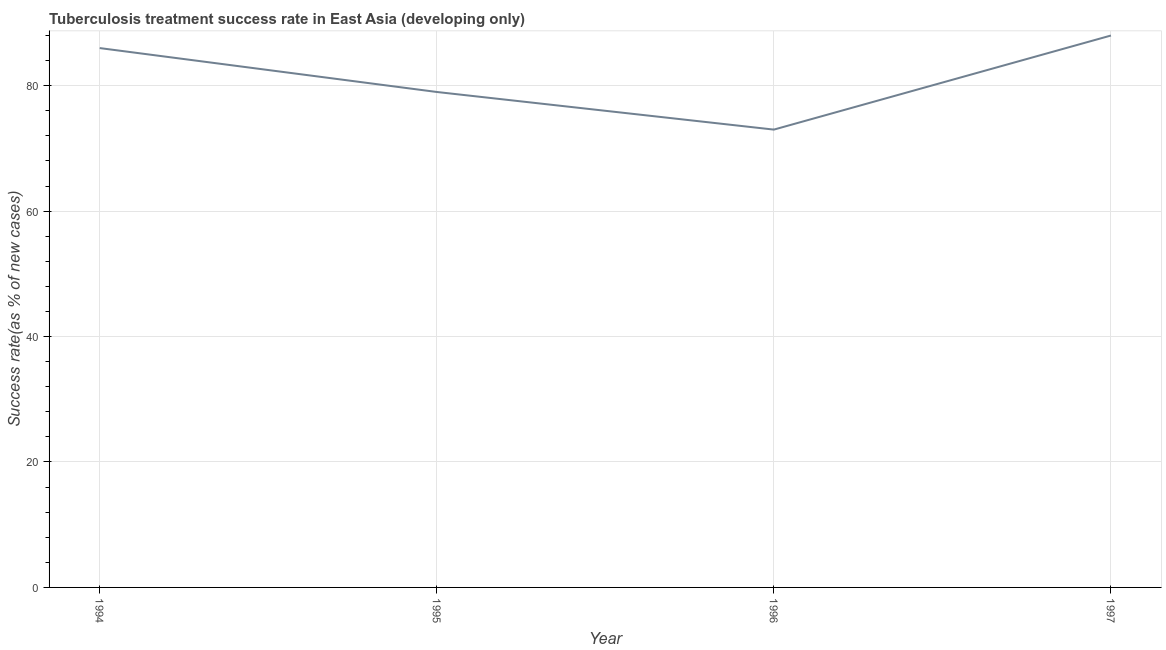What is the tuberculosis treatment success rate in 1996?
Provide a succinct answer. 73. Across all years, what is the maximum tuberculosis treatment success rate?
Offer a very short reply. 88. Across all years, what is the minimum tuberculosis treatment success rate?
Offer a very short reply. 73. In which year was the tuberculosis treatment success rate maximum?
Offer a terse response. 1997. In which year was the tuberculosis treatment success rate minimum?
Your answer should be compact. 1996. What is the sum of the tuberculosis treatment success rate?
Your answer should be compact. 326. What is the difference between the tuberculosis treatment success rate in 1994 and 1997?
Make the answer very short. -2. What is the average tuberculosis treatment success rate per year?
Ensure brevity in your answer.  81.5. What is the median tuberculosis treatment success rate?
Your response must be concise. 82.5. What is the ratio of the tuberculosis treatment success rate in 1995 to that in 1997?
Make the answer very short. 0.9. What is the difference between the highest and the second highest tuberculosis treatment success rate?
Your answer should be compact. 2. Is the sum of the tuberculosis treatment success rate in 1994 and 1997 greater than the maximum tuberculosis treatment success rate across all years?
Your answer should be very brief. Yes. What is the difference between the highest and the lowest tuberculosis treatment success rate?
Ensure brevity in your answer.  15. How many lines are there?
Your answer should be very brief. 1. How many years are there in the graph?
Provide a short and direct response. 4. Does the graph contain any zero values?
Keep it short and to the point. No. Does the graph contain grids?
Give a very brief answer. Yes. What is the title of the graph?
Your response must be concise. Tuberculosis treatment success rate in East Asia (developing only). What is the label or title of the Y-axis?
Provide a succinct answer. Success rate(as % of new cases). What is the Success rate(as % of new cases) in 1994?
Keep it short and to the point. 86. What is the Success rate(as % of new cases) in 1995?
Give a very brief answer. 79. What is the Success rate(as % of new cases) in 1996?
Make the answer very short. 73. What is the Success rate(as % of new cases) of 1997?
Your answer should be very brief. 88. What is the difference between the Success rate(as % of new cases) in 1994 and 1995?
Make the answer very short. 7. What is the ratio of the Success rate(as % of new cases) in 1994 to that in 1995?
Offer a very short reply. 1.09. What is the ratio of the Success rate(as % of new cases) in 1994 to that in 1996?
Your response must be concise. 1.18. What is the ratio of the Success rate(as % of new cases) in 1995 to that in 1996?
Give a very brief answer. 1.08. What is the ratio of the Success rate(as % of new cases) in 1995 to that in 1997?
Your answer should be compact. 0.9. What is the ratio of the Success rate(as % of new cases) in 1996 to that in 1997?
Your answer should be compact. 0.83. 